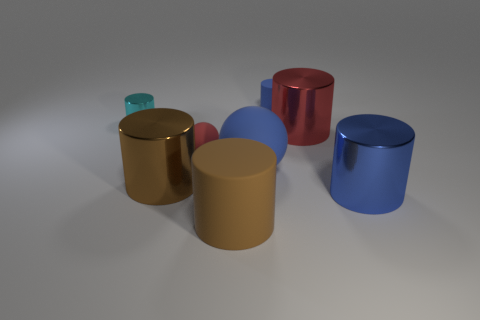What material is the blue object that is on the left side of the small cylinder that is behind the small object that is left of the small rubber sphere made of?
Offer a terse response. Rubber. How many other things are there of the same size as the blue shiny thing?
Provide a short and direct response. 4. The tiny matte sphere has what color?
Provide a succinct answer. Red. How many metal objects are large blue objects or large brown objects?
Your answer should be compact. 2. Are there any other things that have the same material as the blue sphere?
Provide a succinct answer. Yes. There is a rubber sphere to the right of the brown object in front of the large thing on the right side of the large red metallic object; how big is it?
Your response must be concise. Large. There is a cylinder that is both behind the brown metal cylinder and in front of the cyan thing; how big is it?
Offer a terse response. Large. There is a large object behind the blue rubber ball; is its color the same as the tiny cylinder that is on the left side of the tiny rubber cylinder?
Give a very brief answer. No. There is a large blue metallic thing; how many objects are behind it?
Your answer should be compact. 6. Are there any red spheres behind the big blue object left of the large blue thing that is in front of the large brown metallic object?
Offer a very short reply. Yes. 